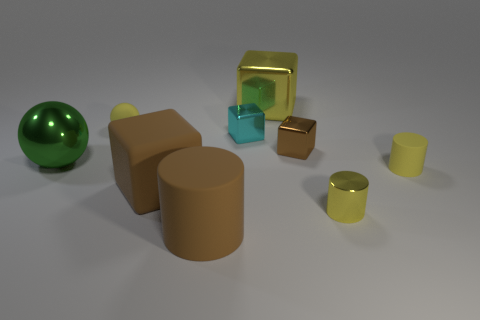Do the tiny shiny cylinder and the big metallic block have the same color?
Your response must be concise. Yes. How many tiny things are either yellow spheres or brown rubber blocks?
Offer a terse response. 1. What is the color of the object that is both behind the yellow metal cylinder and to the right of the small brown object?
Give a very brief answer. Yellow. Are the tiny yellow sphere and the small cyan object made of the same material?
Provide a short and direct response. No. The cyan metallic object is what shape?
Provide a succinct answer. Cube. There is a tiny metallic object that is left of the yellow metallic thing behind the small yellow matte cylinder; how many big yellow metal objects are behind it?
Offer a terse response. 1. What color is the other rubber object that is the same shape as the small brown thing?
Give a very brief answer. Brown. What is the shape of the yellow matte object left of the large block in front of the tiny object that is behind the tiny cyan metallic block?
Your response must be concise. Sphere. There is a rubber thing that is behind the brown rubber block and right of the tiny rubber ball; how big is it?
Provide a short and direct response. Small. Is the number of cyan things less than the number of small metal things?
Provide a succinct answer. Yes. 